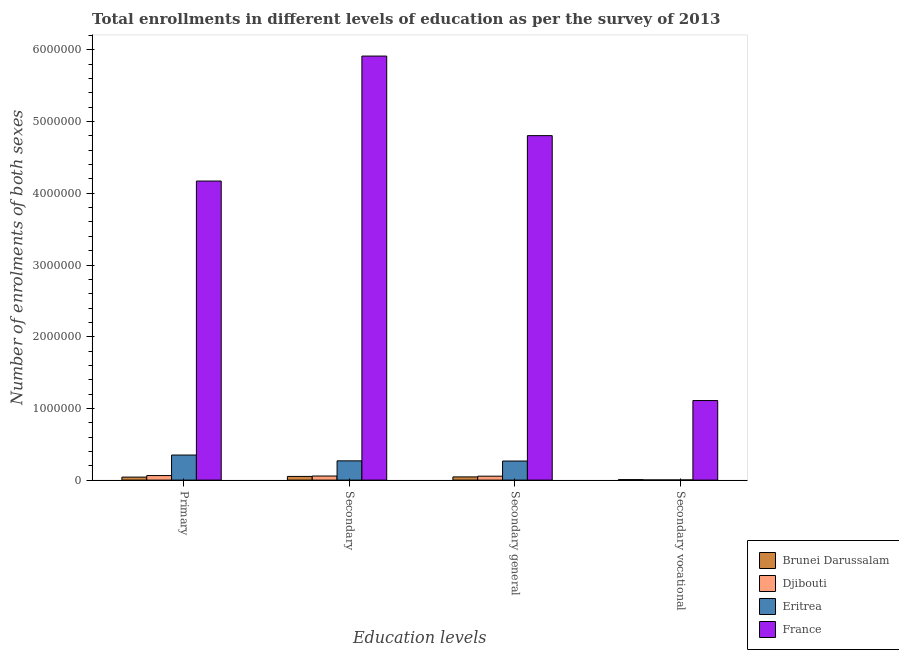How many different coloured bars are there?
Make the answer very short. 4. How many bars are there on the 1st tick from the right?
Make the answer very short. 4. What is the label of the 2nd group of bars from the left?
Offer a very short reply. Secondary. What is the number of enrolments in secondary vocational education in France?
Your answer should be very brief. 1.11e+06. Across all countries, what is the maximum number of enrolments in secondary vocational education?
Your response must be concise. 1.11e+06. Across all countries, what is the minimum number of enrolments in secondary general education?
Keep it short and to the point. 4.49e+04. In which country was the number of enrolments in secondary vocational education minimum?
Provide a succinct answer. Djibouti. What is the total number of enrolments in primary education in the graph?
Ensure brevity in your answer.  4.63e+06. What is the difference between the number of enrolments in primary education in Brunei Darussalam and that in Eritrea?
Keep it short and to the point. -3.08e+05. What is the difference between the number of enrolments in primary education in France and the number of enrolments in secondary vocational education in Eritrea?
Give a very brief answer. 4.17e+06. What is the average number of enrolments in primary education per country?
Give a very brief answer. 1.16e+06. What is the difference between the number of enrolments in secondary vocational education and number of enrolments in secondary education in Djibouti?
Ensure brevity in your answer.  -5.48e+04. In how many countries, is the number of enrolments in primary education greater than 5400000 ?
Keep it short and to the point. 0. What is the ratio of the number of enrolments in secondary vocational education in Djibouti to that in France?
Ensure brevity in your answer.  0. Is the number of enrolments in primary education in Brunei Darussalam less than that in France?
Give a very brief answer. Yes. What is the difference between the highest and the second highest number of enrolments in primary education?
Offer a terse response. 3.82e+06. What is the difference between the highest and the lowest number of enrolments in secondary vocational education?
Provide a succinct answer. 1.11e+06. In how many countries, is the number of enrolments in primary education greater than the average number of enrolments in primary education taken over all countries?
Your answer should be very brief. 1. What does the 1st bar from the left in Secondary general represents?
Keep it short and to the point. Brunei Darussalam. What does the 2nd bar from the right in Secondary general represents?
Offer a terse response. Eritrea. Are all the bars in the graph horizontal?
Your answer should be very brief. No. What is the difference between two consecutive major ticks on the Y-axis?
Give a very brief answer. 1.00e+06. Does the graph contain any zero values?
Your response must be concise. No. Where does the legend appear in the graph?
Your answer should be compact. Bottom right. How many legend labels are there?
Keep it short and to the point. 4. What is the title of the graph?
Make the answer very short. Total enrollments in different levels of education as per the survey of 2013. What is the label or title of the X-axis?
Give a very brief answer. Education levels. What is the label or title of the Y-axis?
Your answer should be compact. Number of enrolments of both sexes. What is the Number of enrolments of both sexes in Brunei Darussalam in Primary?
Ensure brevity in your answer.  4.21e+04. What is the Number of enrolments of both sexes in Djibouti in Primary?
Your answer should be very brief. 6.34e+04. What is the Number of enrolments of both sexes in Eritrea in Primary?
Keep it short and to the point. 3.50e+05. What is the Number of enrolments of both sexes in France in Primary?
Your response must be concise. 4.17e+06. What is the Number of enrolments of both sexes of Brunei Darussalam in Secondary?
Your response must be concise. 5.17e+04. What is the Number of enrolments of both sexes in Djibouti in Secondary?
Make the answer very short. 5.72e+04. What is the Number of enrolments of both sexes of Eritrea in Secondary?
Offer a terse response. 2.69e+05. What is the Number of enrolments of both sexes of France in Secondary?
Make the answer very short. 5.91e+06. What is the Number of enrolments of both sexes of Brunei Darussalam in Secondary general?
Ensure brevity in your answer.  4.49e+04. What is the Number of enrolments of both sexes of Djibouti in Secondary general?
Offer a terse response. 5.48e+04. What is the Number of enrolments of both sexes of Eritrea in Secondary general?
Ensure brevity in your answer.  2.66e+05. What is the Number of enrolments of both sexes in France in Secondary general?
Provide a succinct answer. 4.80e+06. What is the Number of enrolments of both sexes of Brunei Darussalam in Secondary vocational?
Make the answer very short. 6861. What is the Number of enrolments of both sexes of Djibouti in Secondary vocational?
Your response must be concise. 2338. What is the Number of enrolments of both sexes in Eritrea in Secondary vocational?
Ensure brevity in your answer.  2470. What is the Number of enrolments of both sexes of France in Secondary vocational?
Your answer should be very brief. 1.11e+06. Across all Education levels, what is the maximum Number of enrolments of both sexes of Brunei Darussalam?
Offer a terse response. 5.17e+04. Across all Education levels, what is the maximum Number of enrolments of both sexes of Djibouti?
Provide a succinct answer. 6.34e+04. Across all Education levels, what is the maximum Number of enrolments of both sexes of Eritrea?
Ensure brevity in your answer.  3.50e+05. Across all Education levels, what is the maximum Number of enrolments of both sexes in France?
Your response must be concise. 5.91e+06. Across all Education levels, what is the minimum Number of enrolments of both sexes of Brunei Darussalam?
Offer a terse response. 6861. Across all Education levels, what is the minimum Number of enrolments of both sexes in Djibouti?
Your answer should be very brief. 2338. Across all Education levels, what is the minimum Number of enrolments of both sexes in Eritrea?
Ensure brevity in your answer.  2470. Across all Education levels, what is the minimum Number of enrolments of both sexes in France?
Give a very brief answer. 1.11e+06. What is the total Number of enrolments of both sexes of Brunei Darussalam in the graph?
Keep it short and to the point. 1.46e+05. What is the total Number of enrolments of both sexes of Djibouti in the graph?
Offer a terse response. 1.78e+05. What is the total Number of enrolments of both sexes in Eritrea in the graph?
Offer a terse response. 8.87e+05. What is the total Number of enrolments of both sexes in France in the graph?
Provide a succinct answer. 1.60e+07. What is the difference between the Number of enrolments of both sexes of Brunei Darussalam in Primary and that in Secondary?
Offer a very short reply. -9648. What is the difference between the Number of enrolments of both sexes in Djibouti in Primary and that in Secondary?
Offer a terse response. 6213. What is the difference between the Number of enrolments of both sexes of Eritrea in Primary and that in Secondary?
Your answer should be compact. 8.10e+04. What is the difference between the Number of enrolments of both sexes in France in Primary and that in Secondary?
Offer a terse response. -1.74e+06. What is the difference between the Number of enrolments of both sexes in Brunei Darussalam in Primary and that in Secondary general?
Offer a very short reply. -2787. What is the difference between the Number of enrolments of both sexes of Djibouti in Primary and that in Secondary general?
Your response must be concise. 8551. What is the difference between the Number of enrolments of both sexes of Eritrea in Primary and that in Secondary general?
Provide a short and direct response. 8.35e+04. What is the difference between the Number of enrolments of both sexes of France in Primary and that in Secondary general?
Your answer should be compact. -6.33e+05. What is the difference between the Number of enrolments of both sexes in Brunei Darussalam in Primary and that in Secondary vocational?
Your answer should be very brief. 3.52e+04. What is the difference between the Number of enrolments of both sexes of Djibouti in Primary and that in Secondary vocational?
Provide a succinct answer. 6.10e+04. What is the difference between the Number of enrolments of both sexes of Eritrea in Primary and that in Secondary vocational?
Offer a very short reply. 3.47e+05. What is the difference between the Number of enrolments of both sexes in France in Primary and that in Secondary vocational?
Provide a short and direct response. 3.06e+06. What is the difference between the Number of enrolments of both sexes of Brunei Darussalam in Secondary and that in Secondary general?
Ensure brevity in your answer.  6861. What is the difference between the Number of enrolments of both sexes in Djibouti in Secondary and that in Secondary general?
Your answer should be compact. 2338. What is the difference between the Number of enrolments of both sexes in Eritrea in Secondary and that in Secondary general?
Ensure brevity in your answer.  2470. What is the difference between the Number of enrolments of both sexes in France in Secondary and that in Secondary general?
Offer a terse response. 1.11e+06. What is the difference between the Number of enrolments of both sexes in Brunei Darussalam in Secondary and that in Secondary vocational?
Make the answer very short. 4.49e+04. What is the difference between the Number of enrolments of both sexes in Djibouti in Secondary and that in Secondary vocational?
Make the answer very short. 5.48e+04. What is the difference between the Number of enrolments of both sexes in Eritrea in Secondary and that in Secondary vocational?
Offer a terse response. 2.66e+05. What is the difference between the Number of enrolments of both sexes of France in Secondary and that in Secondary vocational?
Make the answer very short. 4.80e+06. What is the difference between the Number of enrolments of both sexes in Brunei Darussalam in Secondary general and that in Secondary vocational?
Your answer should be very brief. 3.80e+04. What is the difference between the Number of enrolments of both sexes in Djibouti in Secondary general and that in Secondary vocational?
Offer a terse response. 5.25e+04. What is the difference between the Number of enrolments of both sexes of Eritrea in Secondary general and that in Secondary vocational?
Ensure brevity in your answer.  2.64e+05. What is the difference between the Number of enrolments of both sexes of France in Secondary general and that in Secondary vocational?
Ensure brevity in your answer.  3.69e+06. What is the difference between the Number of enrolments of both sexes of Brunei Darussalam in Primary and the Number of enrolments of both sexes of Djibouti in Secondary?
Give a very brief answer. -1.51e+04. What is the difference between the Number of enrolments of both sexes in Brunei Darussalam in Primary and the Number of enrolments of both sexes in Eritrea in Secondary?
Give a very brief answer. -2.27e+05. What is the difference between the Number of enrolments of both sexes in Brunei Darussalam in Primary and the Number of enrolments of both sexes in France in Secondary?
Give a very brief answer. -5.87e+06. What is the difference between the Number of enrolments of both sexes in Djibouti in Primary and the Number of enrolments of both sexes in Eritrea in Secondary?
Provide a short and direct response. -2.05e+05. What is the difference between the Number of enrolments of both sexes in Djibouti in Primary and the Number of enrolments of both sexes in France in Secondary?
Make the answer very short. -5.85e+06. What is the difference between the Number of enrolments of both sexes in Eritrea in Primary and the Number of enrolments of both sexes in France in Secondary?
Offer a very short reply. -5.56e+06. What is the difference between the Number of enrolments of both sexes in Brunei Darussalam in Primary and the Number of enrolments of both sexes in Djibouti in Secondary general?
Ensure brevity in your answer.  -1.27e+04. What is the difference between the Number of enrolments of both sexes of Brunei Darussalam in Primary and the Number of enrolments of both sexes of Eritrea in Secondary general?
Ensure brevity in your answer.  -2.24e+05. What is the difference between the Number of enrolments of both sexes of Brunei Darussalam in Primary and the Number of enrolments of both sexes of France in Secondary general?
Make the answer very short. -4.76e+06. What is the difference between the Number of enrolments of both sexes in Djibouti in Primary and the Number of enrolments of both sexes in Eritrea in Secondary general?
Give a very brief answer. -2.03e+05. What is the difference between the Number of enrolments of both sexes of Djibouti in Primary and the Number of enrolments of both sexes of France in Secondary general?
Keep it short and to the point. -4.74e+06. What is the difference between the Number of enrolments of both sexes in Eritrea in Primary and the Number of enrolments of both sexes in France in Secondary general?
Offer a terse response. -4.45e+06. What is the difference between the Number of enrolments of both sexes of Brunei Darussalam in Primary and the Number of enrolments of both sexes of Djibouti in Secondary vocational?
Your answer should be compact. 3.98e+04. What is the difference between the Number of enrolments of both sexes of Brunei Darussalam in Primary and the Number of enrolments of both sexes of Eritrea in Secondary vocational?
Provide a succinct answer. 3.96e+04. What is the difference between the Number of enrolments of both sexes in Brunei Darussalam in Primary and the Number of enrolments of both sexes in France in Secondary vocational?
Provide a succinct answer. -1.07e+06. What is the difference between the Number of enrolments of both sexes of Djibouti in Primary and the Number of enrolments of both sexes of Eritrea in Secondary vocational?
Give a very brief answer. 6.09e+04. What is the difference between the Number of enrolments of both sexes of Djibouti in Primary and the Number of enrolments of both sexes of France in Secondary vocational?
Ensure brevity in your answer.  -1.05e+06. What is the difference between the Number of enrolments of both sexes of Eritrea in Primary and the Number of enrolments of both sexes of France in Secondary vocational?
Give a very brief answer. -7.60e+05. What is the difference between the Number of enrolments of both sexes of Brunei Darussalam in Secondary and the Number of enrolments of both sexes of Djibouti in Secondary general?
Ensure brevity in your answer.  -3079. What is the difference between the Number of enrolments of both sexes of Brunei Darussalam in Secondary and the Number of enrolments of both sexes of Eritrea in Secondary general?
Ensure brevity in your answer.  -2.14e+05. What is the difference between the Number of enrolments of both sexes in Brunei Darussalam in Secondary and the Number of enrolments of both sexes in France in Secondary general?
Your response must be concise. -4.75e+06. What is the difference between the Number of enrolments of both sexes in Djibouti in Secondary and the Number of enrolments of both sexes in Eritrea in Secondary general?
Give a very brief answer. -2.09e+05. What is the difference between the Number of enrolments of both sexes in Djibouti in Secondary and the Number of enrolments of both sexes in France in Secondary general?
Give a very brief answer. -4.75e+06. What is the difference between the Number of enrolments of both sexes in Eritrea in Secondary and the Number of enrolments of both sexes in France in Secondary general?
Keep it short and to the point. -4.54e+06. What is the difference between the Number of enrolments of both sexes of Brunei Darussalam in Secondary and the Number of enrolments of both sexes of Djibouti in Secondary vocational?
Make the answer very short. 4.94e+04. What is the difference between the Number of enrolments of both sexes of Brunei Darussalam in Secondary and the Number of enrolments of both sexes of Eritrea in Secondary vocational?
Your answer should be compact. 4.93e+04. What is the difference between the Number of enrolments of both sexes in Brunei Darussalam in Secondary and the Number of enrolments of both sexes in France in Secondary vocational?
Give a very brief answer. -1.06e+06. What is the difference between the Number of enrolments of both sexes of Djibouti in Secondary and the Number of enrolments of both sexes of Eritrea in Secondary vocational?
Ensure brevity in your answer.  5.47e+04. What is the difference between the Number of enrolments of both sexes of Djibouti in Secondary and the Number of enrolments of both sexes of France in Secondary vocational?
Offer a terse response. -1.05e+06. What is the difference between the Number of enrolments of both sexes in Eritrea in Secondary and the Number of enrolments of both sexes in France in Secondary vocational?
Your response must be concise. -8.41e+05. What is the difference between the Number of enrolments of both sexes of Brunei Darussalam in Secondary general and the Number of enrolments of both sexes of Djibouti in Secondary vocational?
Ensure brevity in your answer.  4.25e+04. What is the difference between the Number of enrolments of both sexes in Brunei Darussalam in Secondary general and the Number of enrolments of both sexes in Eritrea in Secondary vocational?
Offer a very short reply. 4.24e+04. What is the difference between the Number of enrolments of both sexes in Brunei Darussalam in Secondary general and the Number of enrolments of both sexes in France in Secondary vocational?
Provide a succinct answer. -1.06e+06. What is the difference between the Number of enrolments of both sexes of Djibouti in Secondary general and the Number of enrolments of both sexes of Eritrea in Secondary vocational?
Keep it short and to the point. 5.23e+04. What is the difference between the Number of enrolments of both sexes in Djibouti in Secondary general and the Number of enrolments of both sexes in France in Secondary vocational?
Provide a short and direct response. -1.05e+06. What is the difference between the Number of enrolments of both sexes of Eritrea in Secondary general and the Number of enrolments of both sexes of France in Secondary vocational?
Provide a short and direct response. -8.43e+05. What is the average Number of enrolments of both sexes of Brunei Darussalam per Education levels?
Your answer should be very brief. 3.64e+04. What is the average Number of enrolments of both sexes of Djibouti per Education levels?
Your answer should be compact. 4.44e+04. What is the average Number of enrolments of both sexes in Eritrea per Education levels?
Provide a succinct answer. 2.22e+05. What is the average Number of enrolments of both sexes in France per Education levels?
Offer a terse response. 4.00e+06. What is the difference between the Number of enrolments of both sexes in Brunei Darussalam and Number of enrolments of both sexes in Djibouti in Primary?
Make the answer very short. -2.13e+04. What is the difference between the Number of enrolments of both sexes in Brunei Darussalam and Number of enrolments of both sexes in Eritrea in Primary?
Ensure brevity in your answer.  -3.08e+05. What is the difference between the Number of enrolments of both sexes in Brunei Darussalam and Number of enrolments of both sexes in France in Primary?
Keep it short and to the point. -4.13e+06. What is the difference between the Number of enrolments of both sexes in Djibouti and Number of enrolments of both sexes in Eritrea in Primary?
Provide a succinct answer. -2.86e+05. What is the difference between the Number of enrolments of both sexes of Djibouti and Number of enrolments of both sexes of France in Primary?
Offer a very short reply. -4.11e+06. What is the difference between the Number of enrolments of both sexes in Eritrea and Number of enrolments of both sexes in France in Primary?
Offer a very short reply. -3.82e+06. What is the difference between the Number of enrolments of both sexes of Brunei Darussalam and Number of enrolments of both sexes of Djibouti in Secondary?
Your response must be concise. -5417. What is the difference between the Number of enrolments of both sexes in Brunei Darussalam and Number of enrolments of both sexes in Eritrea in Secondary?
Keep it short and to the point. -2.17e+05. What is the difference between the Number of enrolments of both sexes in Brunei Darussalam and Number of enrolments of both sexes in France in Secondary?
Ensure brevity in your answer.  -5.86e+06. What is the difference between the Number of enrolments of both sexes of Djibouti and Number of enrolments of both sexes of Eritrea in Secondary?
Provide a short and direct response. -2.11e+05. What is the difference between the Number of enrolments of both sexes in Djibouti and Number of enrolments of both sexes in France in Secondary?
Offer a very short reply. -5.86e+06. What is the difference between the Number of enrolments of both sexes in Eritrea and Number of enrolments of both sexes in France in Secondary?
Your response must be concise. -5.65e+06. What is the difference between the Number of enrolments of both sexes in Brunei Darussalam and Number of enrolments of both sexes in Djibouti in Secondary general?
Your response must be concise. -9940. What is the difference between the Number of enrolments of both sexes in Brunei Darussalam and Number of enrolments of both sexes in Eritrea in Secondary general?
Give a very brief answer. -2.21e+05. What is the difference between the Number of enrolments of both sexes in Brunei Darussalam and Number of enrolments of both sexes in France in Secondary general?
Give a very brief answer. -4.76e+06. What is the difference between the Number of enrolments of both sexes in Djibouti and Number of enrolments of both sexes in Eritrea in Secondary general?
Make the answer very short. -2.11e+05. What is the difference between the Number of enrolments of both sexes of Djibouti and Number of enrolments of both sexes of France in Secondary general?
Provide a succinct answer. -4.75e+06. What is the difference between the Number of enrolments of both sexes in Eritrea and Number of enrolments of both sexes in France in Secondary general?
Your answer should be compact. -4.54e+06. What is the difference between the Number of enrolments of both sexes of Brunei Darussalam and Number of enrolments of both sexes of Djibouti in Secondary vocational?
Your answer should be compact. 4523. What is the difference between the Number of enrolments of both sexes in Brunei Darussalam and Number of enrolments of both sexes in Eritrea in Secondary vocational?
Your answer should be compact. 4391. What is the difference between the Number of enrolments of both sexes in Brunei Darussalam and Number of enrolments of both sexes in France in Secondary vocational?
Your answer should be very brief. -1.10e+06. What is the difference between the Number of enrolments of both sexes in Djibouti and Number of enrolments of both sexes in Eritrea in Secondary vocational?
Ensure brevity in your answer.  -132. What is the difference between the Number of enrolments of both sexes of Djibouti and Number of enrolments of both sexes of France in Secondary vocational?
Ensure brevity in your answer.  -1.11e+06. What is the difference between the Number of enrolments of both sexes of Eritrea and Number of enrolments of both sexes of France in Secondary vocational?
Offer a terse response. -1.11e+06. What is the ratio of the Number of enrolments of both sexes in Brunei Darussalam in Primary to that in Secondary?
Your answer should be very brief. 0.81. What is the ratio of the Number of enrolments of both sexes in Djibouti in Primary to that in Secondary?
Ensure brevity in your answer.  1.11. What is the ratio of the Number of enrolments of both sexes in Eritrea in Primary to that in Secondary?
Your response must be concise. 1.3. What is the ratio of the Number of enrolments of both sexes of France in Primary to that in Secondary?
Keep it short and to the point. 0.71. What is the ratio of the Number of enrolments of both sexes of Brunei Darussalam in Primary to that in Secondary general?
Make the answer very short. 0.94. What is the ratio of the Number of enrolments of both sexes in Djibouti in Primary to that in Secondary general?
Offer a very short reply. 1.16. What is the ratio of the Number of enrolments of both sexes of Eritrea in Primary to that in Secondary general?
Give a very brief answer. 1.31. What is the ratio of the Number of enrolments of both sexes of France in Primary to that in Secondary general?
Give a very brief answer. 0.87. What is the ratio of the Number of enrolments of both sexes of Brunei Darussalam in Primary to that in Secondary vocational?
Offer a terse response. 6.13. What is the ratio of the Number of enrolments of both sexes of Djibouti in Primary to that in Secondary vocational?
Provide a short and direct response. 27.1. What is the ratio of the Number of enrolments of both sexes in Eritrea in Primary to that in Secondary vocational?
Your response must be concise. 141.56. What is the ratio of the Number of enrolments of both sexes of France in Primary to that in Secondary vocational?
Ensure brevity in your answer.  3.76. What is the ratio of the Number of enrolments of both sexes of Brunei Darussalam in Secondary to that in Secondary general?
Keep it short and to the point. 1.15. What is the ratio of the Number of enrolments of both sexes in Djibouti in Secondary to that in Secondary general?
Offer a terse response. 1.04. What is the ratio of the Number of enrolments of both sexes of Eritrea in Secondary to that in Secondary general?
Your response must be concise. 1.01. What is the ratio of the Number of enrolments of both sexes in France in Secondary to that in Secondary general?
Your response must be concise. 1.23. What is the ratio of the Number of enrolments of both sexes of Brunei Darussalam in Secondary to that in Secondary vocational?
Ensure brevity in your answer.  7.54. What is the ratio of the Number of enrolments of both sexes in Djibouti in Secondary to that in Secondary vocational?
Offer a very short reply. 24.45. What is the ratio of the Number of enrolments of both sexes of Eritrea in Secondary to that in Secondary vocational?
Your answer should be very brief. 108.76. What is the ratio of the Number of enrolments of both sexes in France in Secondary to that in Secondary vocational?
Offer a terse response. 5.33. What is the ratio of the Number of enrolments of both sexes in Brunei Darussalam in Secondary general to that in Secondary vocational?
Your answer should be very brief. 6.54. What is the ratio of the Number of enrolments of both sexes of Djibouti in Secondary general to that in Secondary vocational?
Give a very brief answer. 23.45. What is the ratio of the Number of enrolments of both sexes of Eritrea in Secondary general to that in Secondary vocational?
Provide a succinct answer. 107.76. What is the ratio of the Number of enrolments of both sexes of France in Secondary general to that in Secondary vocational?
Keep it short and to the point. 4.33. What is the difference between the highest and the second highest Number of enrolments of both sexes of Brunei Darussalam?
Give a very brief answer. 6861. What is the difference between the highest and the second highest Number of enrolments of both sexes in Djibouti?
Your answer should be compact. 6213. What is the difference between the highest and the second highest Number of enrolments of both sexes of Eritrea?
Your answer should be compact. 8.10e+04. What is the difference between the highest and the second highest Number of enrolments of both sexes in France?
Your response must be concise. 1.11e+06. What is the difference between the highest and the lowest Number of enrolments of both sexes in Brunei Darussalam?
Ensure brevity in your answer.  4.49e+04. What is the difference between the highest and the lowest Number of enrolments of both sexes of Djibouti?
Make the answer very short. 6.10e+04. What is the difference between the highest and the lowest Number of enrolments of both sexes of Eritrea?
Ensure brevity in your answer.  3.47e+05. What is the difference between the highest and the lowest Number of enrolments of both sexes of France?
Make the answer very short. 4.80e+06. 